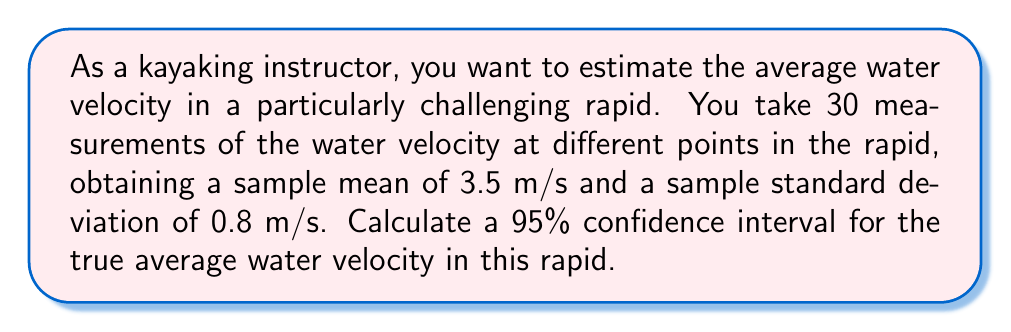Teach me how to tackle this problem. To calculate the confidence interval, we'll follow these steps:

1) The formula for a confidence interval is:

   $$\bar{x} \pm t_{\alpha/2} \cdot \frac{s}{\sqrt{n}}$$

   where $\bar{x}$ is the sample mean, $s$ is the sample standard deviation, $n$ is the sample size, and $t_{\alpha/2}$ is the t-value for a 95% confidence interval with $n-1$ degrees of freedom.

2) We know:
   $\bar{x} = 3.5$ m/s
   $s = 0.8$ m/s
   $n = 30$

3) For a 95% confidence interval with 29 degrees of freedom, $t_{\alpha/2} \approx 2.045$ (from t-distribution table)

4) Calculate the margin of error:

   $$2.045 \cdot \frac{0.8}{\sqrt{30}} \approx 0.2984$$

5) Calculate the lower and upper bounds of the confidence interval:

   Lower bound: $3.5 - 0.2984 = 3.2016$ m/s
   Upper bound: $3.5 + 0.2984 = 3.7984$ m/s

6) Round to two decimal places for practical use.
Answer: (3.20 m/s, 3.80 m/s) 